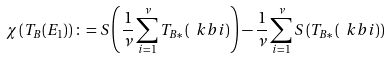<formula> <loc_0><loc_0><loc_500><loc_500>\chi \left ( T _ { B } ( E _ { 1 } ) \right ) \colon = S \left ( \frac { 1 } { \nu } \sum _ { i = 1 } ^ { \nu } T _ { B * } \left ( \ k b { i } \right ) \right ) - \frac { 1 } { \nu } \sum _ { i = 1 } ^ { \nu } S \left ( T _ { B * } \left ( \ k b { i } \right ) \right )</formula> 